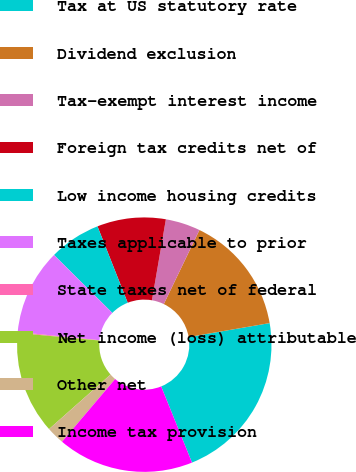Convert chart. <chart><loc_0><loc_0><loc_500><loc_500><pie_chart><fcel>Tax at US statutory rate<fcel>Dividend exclusion<fcel>Tax-exempt interest income<fcel>Foreign tax credits net of<fcel>Low income housing credits<fcel>Taxes applicable to prior<fcel>State taxes net of federal<fcel>Net income (loss) attributable<fcel>Other net<fcel>Income tax provision<nl><fcel>21.59%<fcel>15.15%<fcel>4.42%<fcel>8.71%<fcel>6.56%<fcel>10.86%<fcel>0.12%<fcel>13.01%<fcel>2.27%<fcel>17.3%<nl></chart> 